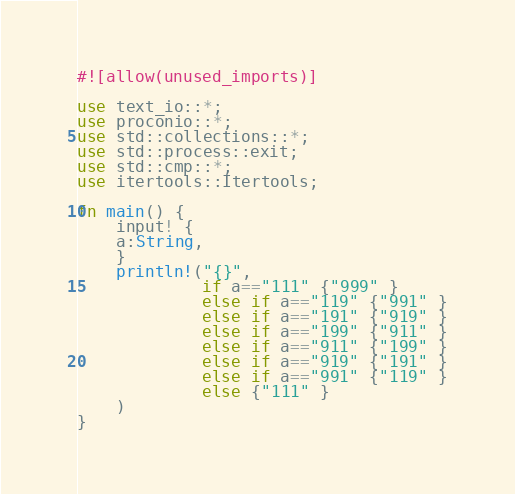<code> <loc_0><loc_0><loc_500><loc_500><_Rust_>#![allow(unused_imports)]

use text_io::*;
use proconio::*;
use std::collections::*;
use std::process::exit;
use std::cmp::*;
use itertools::Itertools;

fn main() {
    input! {
    a:String,
    }
    println!("{}",
             if a=="111" {"999" }
             else if a=="119" {"991" }
             else if a=="191" {"919" }
             else if a=="199" {"911" }
             else if a=="911" {"199" }
             else if a=="919" {"191" }
             else if a=="991" {"119" }
             else {"111" }
    )
}</code> 